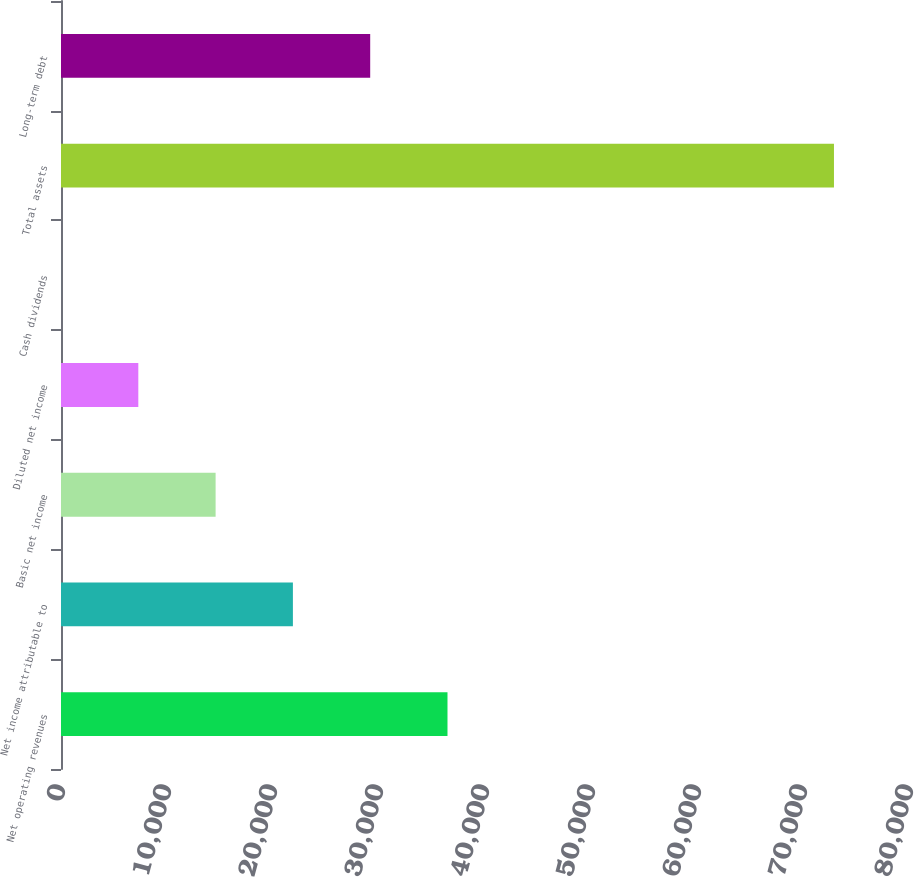<chart> <loc_0><loc_0><loc_500><loc_500><bar_chart><fcel>Net operating revenues<fcel>Net income attributable to<fcel>Basic net income<fcel>Diluted net income<fcel>Cash dividends<fcel>Total assets<fcel>Long-term debt<nl><fcel>36461.4<fcel>21877.5<fcel>14585.6<fcel>7293.68<fcel>1.76<fcel>72921<fcel>29169.4<nl></chart> 